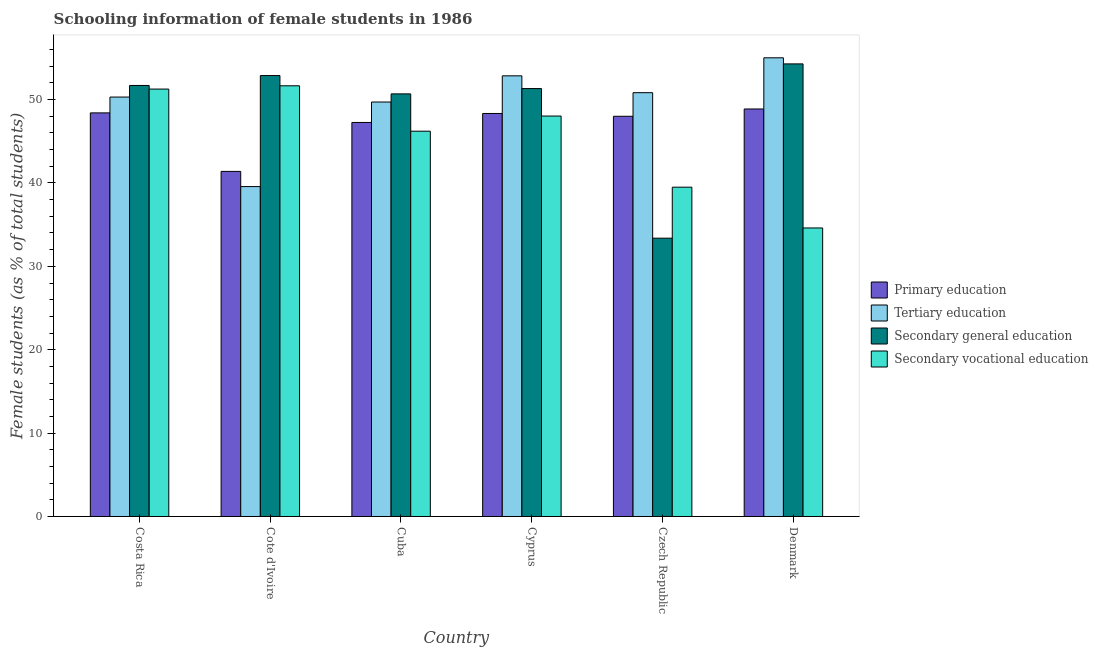How many different coloured bars are there?
Your answer should be very brief. 4. Are the number of bars on each tick of the X-axis equal?
Keep it short and to the point. Yes. How many bars are there on the 2nd tick from the left?
Keep it short and to the point. 4. How many bars are there on the 3rd tick from the right?
Your response must be concise. 4. What is the label of the 1st group of bars from the left?
Offer a very short reply. Costa Rica. What is the percentage of female students in secondary vocational education in Costa Rica?
Offer a very short reply. 51.26. Across all countries, what is the maximum percentage of female students in secondary vocational education?
Your answer should be very brief. 51.65. Across all countries, what is the minimum percentage of female students in secondary vocational education?
Keep it short and to the point. 34.6. In which country was the percentage of female students in secondary education minimum?
Make the answer very short. Czech Republic. What is the total percentage of female students in tertiary education in the graph?
Your answer should be compact. 298.27. What is the difference between the percentage of female students in tertiary education in Cote d'Ivoire and that in Cyprus?
Ensure brevity in your answer.  -13.28. What is the difference between the percentage of female students in secondary education in Cyprus and the percentage of female students in secondary vocational education in Cote d'Ivoire?
Provide a succinct answer. -0.33. What is the average percentage of female students in secondary vocational education per country?
Provide a short and direct response. 45.21. What is the difference between the percentage of female students in secondary vocational education and percentage of female students in primary education in Denmark?
Keep it short and to the point. -14.27. In how many countries, is the percentage of female students in secondary vocational education greater than 44 %?
Your answer should be very brief. 4. What is the ratio of the percentage of female students in tertiary education in Cote d'Ivoire to that in Czech Republic?
Offer a very short reply. 0.78. Is the percentage of female students in secondary education in Cote d'Ivoire less than that in Czech Republic?
Offer a terse response. No. Is the difference between the percentage of female students in tertiary education in Cote d'Ivoire and Cyprus greater than the difference between the percentage of female students in secondary education in Cote d'Ivoire and Cyprus?
Give a very brief answer. No. What is the difference between the highest and the second highest percentage of female students in tertiary education?
Make the answer very short. 2.16. What is the difference between the highest and the lowest percentage of female students in secondary education?
Keep it short and to the point. 20.9. In how many countries, is the percentage of female students in secondary vocational education greater than the average percentage of female students in secondary vocational education taken over all countries?
Offer a terse response. 4. What does the 4th bar from the left in Cyprus represents?
Ensure brevity in your answer.  Secondary vocational education. What does the 2nd bar from the right in Denmark represents?
Ensure brevity in your answer.  Secondary general education. Are all the bars in the graph horizontal?
Give a very brief answer. No. How many countries are there in the graph?
Offer a very short reply. 6. What is the difference between two consecutive major ticks on the Y-axis?
Provide a succinct answer. 10. Are the values on the major ticks of Y-axis written in scientific E-notation?
Your response must be concise. No. Where does the legend appear in the graph?
Offer a terse response. Center right. How many legend labels are there?
Your response must be concise. 4. What is the title of the graph?
Provide a succinct answer. Schooling information of female students in 1986. Does "Mammal species" appear as one of the legend labels in the graph?
Provide a succinct answer. No. What is the label or title of the X-axis?
Your answer should be compact. Country. What is the label or title of the Y-axis?
Provide a short and direct response. Female students (as % of total students). What is the Female students (as % of total students) in Primary education in Costa Rica?
Provide a succinct answer. 48.41. What is the Female students (as % of total students) of Tertiary education in Costa Rica?
Provide a succinct answer. 50.31. What is the Female students (as % of total students) in Secondary general education in Costa Rica?
Offer a very short reply. 51.7. What is the Female students (as % of total students) of Secondary vocational education in Costa Rica?
Ensure brevity in your answer.  51.26. What is the Female students (as % of total students) of Primary education in Cote d'Ivoire?
Provide a succinct answer. 41.39. What is the Female students (as % of total students) in Tertiary education in Cote d'Ivoire?
Keep it short and to the point. 39.57. What is the Female students (as % of total students) of Secondary general education in Cote d'Ivoire?
Offer a terse response. 52.88. What is the Female students (as % of total students) in Secondary vocational education in Cote d'Ivoire?
Make the answer very short. 51.65. What is the Female students (as % of total students) of Primary education in Cuba?
Provide a succinct answer. 47.26. What is the Female students (as % of total students) of Tertiary education in Cuba?
Your answer should be compact. 49.71. What is the Female students (as % of total students) of Secondary general education in Cuba?
Provide a short and direct response. 50.69. What is the Female students (as % of total students) in Secondary vocational education in Cuba?
Your response must be concise. 46.21. What is the Female students (as % of total students) in Primary education in Cyprus?
Your answer should be very brief. 48.33. What is the Female students (as % of total students) of Tertiary education in Cyprus?
Make the answer very short. 52.85. What is the Female students (as % of total students) of Secondary general education in Cyprus?
Offer a terse response. 51.32. What is the Female students (as % of total students) of Secondary vocational education in Cyprus?
Provide a short and direct response. 48.03. What is the Female students (as % of total students) in Primary education in Czech Republic?
Provide a succinct answer. 48. What is the Female students (as % of total students) of Tertiary education in Czech Republic?
Provide a succinct answer. 50.83. What is the Female students (as % of total students) of Secondary general education in Czech Republic?
Your answer should be very brief. 33.38. What is the Female students (as % of total students) in Secondary vocational education in Czech Republic?
Provide a succinct answer. 39.5. What is the Female students (as % of total students) of Primary education in Denmark?
Offer a very short reply. 48.88. What is the Female students (as % of total students) of Tertiary education in Denmark?
Make the answer very short. 55.01. What is the Female students (as % of total students) of Secondary general education in Denmark?
Your response must be concise. 54.28. What is the Female students (as % of total students) in Secondary vocational education in Denmark?
Provide a short and direct response. 34.6. Across all countries, what is the maximum Female students (as % of total students) of Primary education?
Keep it short and to the point. 48.88. Across all countries, what is the maximum Female students (as % of total students) in Tertiary education?
Ensure brevity in your answer.  55.01. Across all countries, what is the maximum Female students (as % of total students) in Secondary general education?
Keep it short and to the point. 54.28. Across all countries, what is the maximum Female students (as % of total students) in Secondary vocational education?
Keep it short and to the point. 51.65. Across all countries, what is the minimum Female students (as % of total students) of Primary education?
Your answer should be compact. 41.39. Across all countries, what is the minimum Female students (as % of total students) in Tertiary education?
Give a very brief answer. 39.57. Across all countries, what is the minimum Female students (as % of total students) in Secondary general education?
Ensure brevity in your answer.  33.38. Across all countries, what is the minimum Female students (as % of total students) of Secondary vocational education?
Give a very brief answer. 34.6. What is the total Female students (as % of total students) of Primary education in the graph?
Ensure brevity in your answer.  282.26. What is the total Female students (as % of total students) of Tertiary education in the graph?
Keep it short and to the point. 298.27. What is the total Female students (as % of total students) of Secondary general education in the graph?
Provide a succinct answer. 294.25. What is the total Female students (as % of total students) of Secondary vocational education in the graph?
Your answer should be very brief. 271.26. What is the difference between the Female students (as % of total students) in Primary education in Costa Rica and that in Cote d'Ivoire?
Offer a very short reply. 7.02. What is the difference between the Female students (as % of total students) in Tertiary education in Costa Rica and that in Cote d'Ivoire?
Give a very brief answer. 10.74. What is the difference between the Female students (as % of total students) of Secondary general education in Costa Rica and that in Cote d'Ivoire?
Provide a succinct answer. -1.19. What is the difference between the Female students (as % of total students) of Secondary vocational education in Costa Rica and that in Cote d'Ivoire?
Provide a short and direct response. -0.39. What is the difference between the Female students (as % of total students) of Primary education in Costa Rica and that in Cuba?
Your answer should be compact. 1.15. What is the difference between the Female students (as % of total students) in Tertiary education in Costa Rica and that in Cuba?
Give a very brief answer. 0.6. What is the difference between the Female students (as % of total students) in Secondary general education in Costa Rica and that in Cuba?
Provide a short and direct response. 1.01. What is the difference between the Female students (as % of total students) in Secondary vocational education in Costa Rica and that in Cuba?
Ensure brevity in your answer.  5.05. What is the difference between the Female students (as % of total students) of Primary education in Costa Rica and that in Cyprus?
Your answer should be compact. 0.07. What is the difference between the Female students (as % of total students) in Tertiary education in Costa Rica and that in Cyprus?
Ensure brevity in your answer.  -2.54. What is the difference between the Female students (as % of total students) of Secondary general education in Costa Rica and that in Cyprus?
Your response must be concise. 0.37. What is the difference between the Female students (as % of total students) in Secondary vocational education in Costa Rica and that in Cyprus?
Provide a short and direct response. 3.23. What is the difference between the Female students (as % of total students) of Primary education in Costa Rica and that in Czech Republic?
Give a very brief answer. 0.41. What is the difference between the Female students (as % of total students) in Tertiary education in Costa Rica and that in Czech Republic?
Offer a terse response. -0.53. What is the difference between the Female students (as % of total students) of Secondary general education in Costa Rica and that in Czech Republic?
Provide a succinct answer. 18.32. What is the difference between the Female students (as % of total students) in Secondary vocational education in Costa Rica and that in Czech Republic?
Your answer should be very brief. 11.77. What is the difference between the Female students (as % of total students) of Primary education in Costa Rica and that in Denmark?
Provide a short and direct response. -0.47. What is the difference between the Female students (as % of total students) of Tertiary education in Costa Rica and that in Denmark?
Give a very brief answer. -4.71. What is the difference between the Female students (as % of total students) of Secondary general education in Costa Rica and that in Denmark?
Give a very brief answer. -2.59. What is the difference between the Female students (as % of total students) of Secondary vocational education in Costa Rica and that in Denmark?
Offer a very short reply. 16.66. What is the difference between the Female students (as % of total students) of Primary education in Cote d'Ivoire and that in Cuba?
Give a very brief answer. -5.87. What is the difference between the Female students (as % of total students) of Tertiary education in Cote d'Ivoire and that in Cuba?
Provide a succinct answer. -10.14. What is the difference between the Female students (as % of total students) of Secondary general education in Cote d'Ivoire and that in Cuba?
Offer a terse response. 2.2. What is the difference between the Female students (as % of total students) of Secondary vocational education in Cote d'Ivoire and that in Cuba?
Provide a succinct answer. 5.44. What is the difference between the Female students (as % of total students) in Primary education in Cote d'Ivoire and that in Cyprus?
Offer a terse response. -6.95. What is the difference between the Female students (as % of total students) of Tertiary education in Cote d'Ivoire and that in Cyprus?
Provide a succinct answer. -13.28. What is the difference between the Female students (as % of total students) in Secondary general education in Cote d'Ivoire and that in Cyprus?
Give a very brief answer. 1.56. What is the difference between the Female students (as % of total students) in Secondary vocational education in Cote d'Ivoire and that in Cyprus?
Your answer should be compact. 3.63. What is the difference between the Female students (as % of total students) in Primary education in Cote d'Ivoire and that in Czech Republic?
Your answer should be very brief. -6.61. What is the difference between the Female students (as % of total students) of Tertiary education in Cote d'Ivoire and that in Czech Republic?
Your answer should be very brief. -11.26. What is the difference between the Female students (as % of total students) in Secondary general education in Cote d'Ivoire and that in Czech Republic?
Ensure brevity in your answer.  19.5. What is the difference between the Female students (as % of total students) in Secondary vocational education in Cote d'Ivoire and that in Czech Republic?
Offer a very short reply. 12.16. What is the difference between the Female students (as % of total students) in Primary education in Cote d'Ivoire and that in Denmark?
Offer a terse response. -7.49. What is the difference between the Female students (as % of total students) of Tertiary education in Cote d'Ivoire and that in Denmark?
Make the answer very short. -15.45. What is the difference between the Female students (as % of total students) in Secondary general education in Cote d'Ivoire and that in Denmark?
Your answer should be compact. -1.4. What is the difference between the Female students (as % of total students) of Secondary vocational education in Cote d'Ivoire and that in Denmark?
Offer a very short reply. 17.05. What is the difference between the Female students (as % of total students) of Primary education in Cuba and that in Cyprus?
Give a very brief answer. -1.08. What is the difference between the Female students (as % of total students) of Tertiary education in Cuba and that in Cyprus?
Keep it short and to the point. -3.14. What is the difference between the Female students (as % of total students) of Secondary general education in Cuba and that in Cyprus?
Ensure brevity in your answer.  -0.64. What is the difference between the Female students (as % of total students) of Secondary vocational education in Cuba and that in Cyprus?
Offer a very short reply. -1.82. What is the difference between the Female students (as % of total students) of Primary education in Cuba and that in Czech Republic?
Provide a short and direct response. -0.74. What is the difference between the Female students (as % of total students) of Tertiary education in Cuba and that in Czech Republic?
Your answer should be compact. -1.12. What is the difference between the Female students (as % of total students) of Secondary general education in Cuba and that in Czech Republic?
Your answer should be compact. 17.31. What is the difference between the Female students (as % of total students) in Secondary vocational education in Cuba and that in Czech Republic?
Provide a succinct answer. 6.71. What is the difference between the Female students (as % of total students) in Primary education in Cuba and that in Denmark?
Offer a terse response. -1.62. What is the difference between the Female students (as % of total students) of Tertiary education in Cuba and that in Denmark?
Keep it short and to the point. -5.3. What is the difference between the Female students (as % of total students) in Secondary general education in Cuba and that in Denmark?
Give a very brief answer. -3.6. What is the difference between the Female students (as % of total students) in Secondary vocational education in Cuba and that in Denmark?
Offer a terse response. 11.61. What is the difference between the Female students (as % of total students) in Primary education in Cyprus and that in Czech Republic?
Keep it short and to the point. 0.34. What is the difference between the Female students (as % of total students) of Tertiary education in Cyprus and that in Czech Republic?
Your answer should be very brief. 2.02. What is the difference between the Female students (as % of total students) of Secondary general education in Cyprus and that in Czech Republic?
Give a very brief answer. 17.94. What is the difference between the Female students (as % of total students) in Secondary vocational education in Cyprus and that in Czech Republic?
Your answer should be compact. 8.53. What is the difference between the Female students (as % of total students) in Primary education in Cyprus and that in Denmark?
Your response must be concise. -0.54. What is the difference between the Female students (as % of total students) of Tertiary education in Cyprus and that in Denmark?
Make the answer very short. -2.16. What is the difference between the Female students (as % of total students) of Secondary general education in Cyprus and that in Denmark?
Keep it short and to the point. -2.96. What is the difference between the Female students (as % of total students) in Secondary vocational education in Cyprus and that in Denmark?
Your response must be concise. 13.42. What is the difference between the Female students (as % of total students) in Primary education in Czech Republic and that in Denmark?
Ensure brevity in your answer.  -0.88. What is the difference between the Female students (as % of total students) of Tertiary education in Czech Republic and that in Denmark?
Ensure brevity in your answer.  -4.18. What is the difference between the Female students (as % of total students) in Secondary general education in Czech Republic and that in Denmark?
Give a very brief answer. -20.9. What is the difference between the Female students (as % of total students) of Secondary vocational education in Czech Republic and that in Denmark?
Ensure brevity in your answer.  4.89. What is the difference between the Female students (as % of total students) in Primary education in Costa Rica and the Female students (as % of total students) in Tertiary education in Cote d'Ivoire?
Make the answer very short. 8.84. What is the difference between the Female students (as % of total students) in Primary education in Costa Rica and the Female students (as % of total students) in Secondary general education in Cote d'Ivoire?
Your answer should be very brief. -4.48. What is the difference between the Female students (as % of total students) of Primary education in Costa Rica and the Female students (as % of total students) of Secondary vocational education in Cote d'Ivoire?
Give a very brief answer. -3.25. What is the difference between the Female students (as % of total students) of Tertiary education in Costa Rica and the Female students (as % of total students) of Secondary general education in Cote d'Ivoire?
Your response must be concise. -2.58. What is the difference between the Female students (as % of total students) in Tertiary education in Costa Rica and the Female students (as % of total students) in Secondary vocational education in Cote d'Ivoire?
Offer a very short reply. -1.35. What is the difference between the Female students (as % of total students) of Secondary general education in Costa Rica and the Female students (as % of total students) of Secondary vocational education in Cote d'Ivoire?
Your answer should be compact. 0.04. What is the difference between the Female students (as % of total students) in Primary education in Costa Rica and the Female students (as % of total students) in Tertiary education in Cuba?
Your answer should be compact. -1.3. What is the difference between the Female students (as % of total students) in Primary education in Costa Rica and the Female students (as % of total students) in Secondary general education in Cuba?
Your answer should be compact. -2.28. What is the difference between the Female students (as % of total students) in Primary education in Costa Rica and the Female students (as % of total students) in Secondary vocational education in Cuba?
Your answer should be very brief. 2.2. What is the difference between the Female students (as % of total students) in Tertiary education in Costa Rica and the Female students (as % of total students) in Secondary general education in Cuba?
Your answer should be very brief. -0.38. What is the difference between the Female students (as % of total students) of Tertiary education in Costa Rica and the Female students (as % of total students) of Secondary vocational education in Cuba?
Make the answer very short. 4.09. What is the difference between the Female students (as % of total students) of Secondary general education in Costa Rica and the Female students (as % of total students) of Secondary vocational education in Cuba?
Keep it short and to the point. 5.48. What is the difference between the Female students (as % of total students) of Primary education in Costa Rica and the Female students (as % of total students) of Tertiary education in Cyprus?
Offer a terse response. -4.44. What is the difference between the Female students (as % of total students) of Primary education in Costa Rica and the Female students (as % of total students) of Secondary general education in Cyprus?
Provide a short and direct response. -2.92. What is the difference between the Female students (as % of total students) in Primary education in Costa Rica and the Female students (as % of total students) in Secondary vocational education in Cyprus?
Provide a short and direct response. 0.38. What is the difference between the Female students (as % of total students) of Tertiary education in Costa Rica and the Female students (as % of total students) of Secondary general education in Cyprus?
Offer a terse response. -1.02. What is the difference between the Female students (as % of total students) of Tertiary education in Costa Rica and the Female students (as % of total students) of Secondary vocational education in Cyprus?
Give a very brief answer. 2.28. What is the difference between the Female students (as % of total students) of Secondary general education in Costa Rica and the Female students (as % of total students) of Secondary vocational education in Cyprus?
Your answer should be compact. 3.67. What is the difference between the Female students (as % of total students) in Primary education in Costa Rica and the Female students (as % of total students) in Tertiary education in Czech Republic?
Keep it short and to the point. -2.42. What is the difference between the Female students (as % of total students) in Primary education in Costa Rica and the Female students (as % of total students) in Secondary general education in Czech Republic?
Provide a short and direct response. 15.03. What is the difference between the Female students (as % of total students) in Primary education in Costa Rica and the Female students (as % of total students) in Secondary vocational education in Czech Republic?
Give a very brief answer. 8.91. What is the difference between the Female students (as % of total students) of Tertiary education in Costa Rica and the Female students (as % of total students) of Secondary general education in Czech Republic?
Offer a very short reply. 16.93. What is the difference between the Female students (as % of total students) of Tertiary education in Costa Rica and the Female students (as % of total students) of Secondary vocational education in Czech Republic?
Your answer should be very brief. 10.81. What is the difference between the Female students (as % of total students) in Secondary general education in Costa Rica and the Female students (as % of total students) in Secondary vocational education in Czech Republic?
Keep it short and to the point. 12.2. What is the difference between the Female students (as % of total students) of Primary education in Costa Rica and the Female students (as % of total students) of Tertiary education in Denmark?
Ensure brevity in your answer.  -6.61. What is the difference between the Female students (as % of total students) in Primary education in Costa Rica and the Female students (as % of total students) in Secondary general education in Denmark?
Provide a succinct answer. -5.88. What is the difference between the Female students (as % of total students) in Primary education in Costa Rica and the Female students (as % of total students) in Secondary vocational education in Denmark?
Make the answer very short. 13.8. What is the difference between the Female students (as % of total students) of Tertiary education in Costa Rica and the Female students (as % of total students) of Secondary general education in Denmark?
Make the answer very short. -3.98. What is the difference between the Female students (as % of total students) in Tertiary education in Costa Rica and the Female students (as % of total students) in Secondary vocational education in Denmark?
Keep it short and to the point. 15.7. What is the difference between the Female students (as % of total students) of Secondary general education in Costa Rica and the Female students (as % of total students) of Secondary vocational education in Denmark?
Ensure brevity in your answer.  17.09. What is the difference between the Female students (as % of total students) in Primary education in Cote d'Ivoire and the Female students (as % of total students) in Tertiary education in Cuba?
Ensure brevity in your answer.  -8.32. What is the difference between the Female students (as % of total students) in Primary education in Cote d'Ivoire and the Female students (as % of total students) in Secondary general education in Cuba?
Make the answer very short. -9.3. What is the difference between the Female students (as % of total students) in Primary education in Cote d'Ivoire and the Female students (as % of total students) in Secondary vocational education in Cuba?
Your answer should be compact. -4.82. What is the difference between the Female students (as % of total students) in Tertiary education in Cote d'Ivoire and the Female students (as % of total students) in Secondary general education in Cuba?
Your response must be concise. -11.12. What is the difference between the Female students (as % of total students) in Tertiary education in Cote d'Ivoire and the Female students (as % of total students) in Secondary vocational education in Cuba?
Your response must be concise. -6.64. What is the difference between the Female students (as % of total students) of Secondary general education in Cote d'Ivoire and the Female students (as % of total students) of Secondary vocational education in Cuba?
Give a very brief answer. 6.67. What is the difference between the Female students (as % of total students) of Primary education in Cote d'Ivoire and the Female students (as % of total students) of Tertiary education in Cyprus?
Your answer should be very brief. -11.46. What is the difference between the Female students (as % of total students) in Primary education in Cote d'Ivoire and the Female students (as % of total students) in Secondary general education in Cyprus?
Make the answer very short. -9.93. What is the difference between the Female students (as % of total students) of Primary education in Cote d'Ivoire and the Female students (as % of total students) of Secondary vocational education in Cyprus?
Provide a succinct answer. -6.64. What is the difference between the Female students (as % of total students) in Tertiary education in Cote d'Ivoire and the Female students (as % of total students) in Secondary general education in Cyprus?
Offer a very short reply. -11.76. What is the difference between the Female students (as % of total students) of Tertiary education in Cote d'Ivoire and the Female students (as % of total students) of Secondary vocational education in Cyprus?
Offer a terse response. -8.46. What is the difference between the Female students (as % of total students) of Secondary general education in Cote d'Ivoire and the Female students (as % of total students) of Secondary vocational education in Cyprus?
Make the answer very short. 4.86. What is the difference between the Female students (as % of total students) in Primary education in Cote d'Ivoire and the Female students (as % of total students) in Tertiary education in Czech Republic?
Your response must be concise. -9.44. What is the difference between the Female students (as % of total students) of Primary education in Cote d'Ivoire and the Female students (as % of total students) of Secondary general education in Czech Republic?
Provide a succinct answer. 8.01. What is the difference between the Female students (as % of total students) of Primary education in Cote d'Ivoire and the Female students (as % of total students) of Secondary vocational education in Czech Republic?
Keep it short and to the point. 1.89. What is the difference between the Female students (as % of total students) of Tertiary education in Cote d'Ivoire and the Female students (as % of total students) of Secondary general education in Czech Republic?
Give a very brief answer. 6.19. What is the difference between the Female students (as % of total students) in Tertiary education in Cote d'Ivoire and the Female students (as % of total students) in Secondary vocational education in Czech Republic?
Your answer should be very brief. 0.07. What is the difference between the Female students (as % of total students) of Secondary general education in Cote d'Ivoire and the Female students (as % of total students) of Secondary vocational education in Czech Republic?
Provide a short and direct response. 13.39. What is the difference between the Female students (as % of total students) of Primary education in Cote d'Ivoire and the Female students (as % of total students) of Tertiary education in Denmark?
Offer a terse response. -13.62. What is the difference between the Female students (as % of total students) in Primary education in Cote d'Ivoire and the Female students (as % of total students) in Secondary general education in Denmark?
Provide a succinct answer. -12.89. What is the difference between the Female students (as % of total students) of Primary education in Cote d'Ivoire and the Female students (as % of total students) of Secondary vocational education in Denmark?
Make the answer very short. 6.78. What is the difference between the Female students (as % of total students) in Tertiary education in Cote d'Ivoire and the Female students (as % of total students) in Secondary general education in Denmark?
Offer a terse response. -14.72. What is the difference between the Female students (as % of total students) of Tertiary education in Cote d'Ivoire and the Female students (as % of total students) of Secondary vocational education in Denmark?
Ensure brevity in your answer.  4.96. What is the difference between the Female students (as % of total students) of Secondary general education in Cote d'Ivoire and the Female students (as % of total students) of Secondary vocational education in Denmark?
Make the answer very short. 18.28. What is the difference between the Female students (as % of total students) of Primary education in Cuba and the Female students (as % of total students) of Tertiary education in Cyprus?
Keep it short and to the point. -5.59. What is the difference between the Female students (as % of total students) of Primary education in Cuba and the Female students (as % of total students) of Secondary general education in Cyprus?
Ensure brevity in your answer.  -4.07. What is the difference between the Female students (as % of total students) of Primary education in Cuba and the Female students (as % of total students) of Secondary vocational education in Cyprus?
Offer a terse response. -0.77. What is the difference between the Female students (as % of total students) of Tertiary education in Cuba and the Female students (as % of total students) of Secondary general education in Cyprus?
Make the answer very short. -1.61. What is the difference between the Female students (as % of total students) of Tertiary education in Cuba and the Female students (as % of total students) of Secondary vocational education in Cyprus?
Make the answer very short. 1.68. What is the difference between the Female students (as % of total students) in Secondary general education in Cuba and the Female students (as % of total students) in Secondary vocational education in Cyprus?
Make the answer very short. 2.66. What is the difference between the Female students (as % of total students) of Primary education in Cuba and the Female students (as % of total students) of Tertiary education in Czech Republic?
Make the answer very short. -3.57. What is the difference between the Female students (as % of total students) in Primary education in Cuba and the Female students (as % of total students) in Secondary general education in Czech Republic?
Your answer should be very brief. 13.88. What is the difference between the Female students (as % of total students) of Primary education in Cuba and the Female students (as % of total students) of Secondary vocational education in Czech Republic?
Your answer should be very brief. 7.76. What is the difference between the Female students (as % of total students) in Tertiary education in Cuba and the Female students (as % of total students) in Secondary general education in Czech Republic?
Your answer should be compact. 16.33. What is the difference between the Female students (as % of total students) of Tertiary education in Cuba and the Female students (as % of total students) of Secondary vocational education in Czech Republic?
Provide a succinct answer. 10.21. What is the difference between the Female students (as % of total students) of Secondary general education in Cuba and the Female students (as % of total students) of Secondary vocational education in Czech Republic?
Give a very brief answer. 11.19. What is the difference between the Female students (as % of total students) of Primary education in Cuba and the Female students (as % of total students) of Tertiary education in Denmark?
Offer a terse response. -7.75. What is the difference between the Female students (as % of total students) in Primary education in Cuba and the Female students (as % of total students) in Secondary general education in Denmark?
Offer a terse response. -7.03. What is the difference between the Female students (as % of total students) of Primary education in Cuba and the Female students (as % of total students) of Secondary vocational education in Denmark?
Provide a succinct answer. 12.65. What is the difference between the Female students (as % of total students) in Tertiary education in Cuba and the Female students (as % of total students) in Secondary general education in Denmark?
Give a very brief answer. -4.57. What is the difference between the Female students (as % of total students) in Tertiary education in Cuba and the Female students (as % of total students) in Secondary vocational education in Denmark?
Offer a terse response. 15.1. What is the difference between the Female students (as % of total students) in Secondary general education in Cuba and the Female students (as % of total students) in Secondary vocational education in Denmark?
Ensure brevity in your answer.  16.08. What is the difference between the Female students (as % of total students) of Primary education in Cyprus and the Female students (as % of total students) of Tertiary education in Czech Republic?
Ensure brevity in your answer.  -2.5. What is the difference between the Female students (as % of total students) in Primary education in Cyprus and the Female students (as % of total students) in Secondary general education in Czech Republic?
Ensure brevity in your answer.  14.96. What is the difference between the Female students (as % of total students) in Primary education in Cyprus and the Female students (as % of total students) in Secondary vocational education in Czech Republic?
Your response must be concise. 8.84. What is the difference between the Female students (as % of total students) of Tertiary education in Cyprus and the Female students (as % of total students) of Secondary general education in Czech Republic?
Make the answer very short. 19.47. What is the difference between the Female students (as % of total students) in Tertiary education in Cyprus and the Female students (as % of total students) in Secondary vocational education in Czech Republic?
Ensure brevity in your answer.  13.35. What is the difference between the Female students (as % of total students) in Secondary general education in Cyprus and the Female students (as % of total students) in Secondary vocational education in Czech Republic?
Give a very brief answer. 11.83. What is the difference between the Female students (as % of total students) in Primary education in Cyprus and the Female students (as % of total students) in Tertiary education in Denmark?
Provide a succinct answer. -6.68. What is the difference between the Female students (as % of total students) in Primary education in Cyprus and the Female students (as % of total students) in Secondary general education in Denmark?
Provide a short and direct response. -5.95. What is the difference between the Female students (as % of total students) in Primary education in Cyprus and the Female students (as % of total students) in Secondary vocational education in Denmark?
Provide a short and direct response. 13.73. What is the difference between the Female students (as % of total students) of Tertiary education in Cyprus and the Female students (as % of total students) of Secondary general education in Denmark?
Your answer should be very brief. -1.43. What is the difference between the Female students (as % of total students) in Tertiary education in Cyprus and the Female students (as % of total students) in Secondary vocational education in Denmark?
Provide a short and direct response. 18.25. What is the difference between the Female students (as % of total students) in Secondary general education in Cyprus and the Female students (as % of total students) in Secondary vocational education in Denmark?
Offer a terse response. 16.72. What is the difference between the Female students (as % of total students) of Primary education in Czech Republic and the Female students (as % of total students) of Tertiary education in Denmark?
Your answer should be compact. -7.01. What is the difference between the Female students (as % of total students) in Primary education in Czech Republic and the Female students (as % of total students) in Secondary general education in Denmark?
Provide a succinct answer. -6.28. What is the difference between the Female students (as % of total students) in Primary education in Czech Republic and the Female students (as % of total students) in Secondary vocational education in Denmark?
Make the answer very short. 13.39. What is the difference between the Female students (as % of total students) of Tertiary education in Czech Republic and the Female students (as % of total students) of Secondary general education in Denmark?
Give a very brief answer. -3.45. What is the difference between the Female students (as % of total students) in Tertiary education in Czech Republic and the Female students (as % of total students) in Secondary vocational education in Denmark?
Offer a very short reply. 16.23. What is the difference between the Female students (as % of total students) in Secondary general education in Czech Republic and the Female students (as % of total students) in Secondary vocational education in Denmark?
Your answer should be compact. -1.23. What is the average Female students (as % of total students) in Primary education per country?
Your response must be concise. 47.04. What is the average Female students (as % of total students) in Tertiary education per country?
Your answer should be very brief. 49.71. What is the average Female students (as % of total students) of Secondary general education per country?
Offer a terse response. 49.04. What is the average Female students (as % of total students) of Secondary vocational education per country?
Make the answer very short. 45.21. What is the difference between the Female students (as % of total students) in Primary education and Female students (as % of total students) in Tertiary education in Costa Rica?
Ensure brevity in your answer.  -1.9. What is the difference between the Female students (as % of total students) in Primary education and Female students (as % of total students) in Secondary general education in Costa Rica?
Offer a terse response. -3.29. What is the difference between the Female students (as % of total students) of Primary education and Female students (as % of total students) of Secondary vocational education in Costa Rica?
Ensure brevity in your answer.  -2.86. What is the difference between the Female students (as % of total students) of Tertiary education and Female students (as % of total students) of Secondary general education in Costa Rica?
Your answer should be very brief. -1.39. What is the difference between the Female students (as % of total students) of Tertiary education and Female students (as % of total students) of Secondary vocational education in Costa Rica?
Your response must be concise. -0.96. What is the difference between the Female students (as % of total students) in Secondary general education and Female students (as % of total students) in Secondary vocational education in Costa Rica?
Provide a short and direct response. 0.43. What is the difference between the Female students (as % of total students) in Primary education and Female students (as % of total students) in Tertiary education in Cote d'Ivoire?
Your answer should be very brief. 1.82. What is the difference between the Female students (as % of total students) in Primary education and Female students (as % of total students) in Secondary general education in Cote d'Ivoire?
Provide a succinct answer. -11.5. What is the difference between the Female students (as % of total students) of Primary education and Female students (as % of total students) of Secondary vocational education in Cote d'Ivoire?
Your response must be concise. -10.27. What is the difference between the Female students (as % of total students) of Tertiary education and Female students (as % of total students) of Secondary general education in Cote d'Ivoire?
Offer a very short reply. -13.32. What is the difference between the Female students (as % of total students) of Tertiary education and Female students (as % of total students) of Secondary vocational education in Cote d'Ivoire?
Provide a short and direct response. -12.09. What is the difference between the Female students (as % of total students) of Secondary general education and Female students (as % of total students) of Secondary vocational education in Cote d'Ivoire?
Give a very brief answer. 1.23. What is the difference between the Female students (as % of total students) of Primary education and Female students (as % of total students) of Tertiary education in Cuba?
Your answer should be compact. -2.45. What is the difference between the Female students (as % of total students) of Primary education and Female students (as % of total students) of Secondary general education in Cuba?
Ensure brevity in your answer.  -3.43. What is the difference between the Female students (as % of total students) of Primary education and Female students (as % of total students) of Secondary vocational education in Cuba?
Your response must be concise. 1.05. What is the difference between the Female students (as % of total students) in Tertiary education and Female students (as % of total students) in Secondary general education in Cuba?
Provide a succinct answer. -0.98. What is the difference between the Female students (as % of total students) in Tertiary education and Female students (as % of total students) in Secondary vocational education in Cuba?
Your answer should be compact. 3.5. What is the difference between the Female students (as % of total students) in Secondary general education and Female students (as % of total students) in Secondary vocational education in Cuba?
Give a very brief answer. 4.47. What is the difference between the Female students (as % of total students) in Primary education and Female students (as % of total students) in Tertiary education in Cyprus?
Offer a very short reply. -4.52. What is the difference between the Female students (as % of total students) in Primary education and Female students (as % of total students) in Secondary general education in Cyprus?
Your answer should be compact. -2.99. What is the difference between the Female students (as % of total students) in Primary education and Female students (as % of total students) in Secondary vocational education in Cyprus?
Keep it short and to the point. 0.31. What is the difference between the Female students (as % of total students) of Tertiary education and Female students (as % of total students) of Secondary general education in Cyprus?
Your answer should be compact. 1.53. What is the difference between the Female students (as % of total students) of Tertiary education and Female students (as % of total students) of Secondary vocational education in Cyprus?
Offer a terse response. 4.82. What is the difference between the Female students (as % of total students) of Secondary general education and Female students (as % of total students) of Secondary vocational education in Cyprus?
Your response must be concise. 3.29. What is the difference between the Female students (as % of total students) in Primary education and Female students (as % of total students) in Tertiary education in Czech Republic?
Provide a succinct answer. -2.83. What is the difference between the Female students (as % of total students) in Primary education and Female students (as % of total students) in Secondary general education in Czech Republic?
Provide a short and direct response. 14.62. What is the difference between the Female students (as % of total students) of Primary education and Female students (as % of total students) of Secondary vocational education in Czech Republic?
Your response must be concise. 8.5. What is the difference between the Female students (as % of total students) of Tertiary education and Female students (as % of total students) of Secondary general education in Czech Republic?
Offer a terse response. 17.45. What is the difference between the Female students (as % of total students) of Tertiary education and Female students (as % of total students) of Secondary vocational education in Czech Republic?
Offer a very short reply. 11.33. What is the difference between the Female students (as % of total students) of Secondary general education and Female students (as % of total students) of Secondary vocational education in Czech Republic?
Make the answer very short. -6.12. What is the difference between the Female students (as % of total students) of Primary education and Female students (as % of total students) of Tertiary education in Denmark?
Keep it short and to the point. -6.14. What is the difference between the Female students (as % of total students) of Primary education and Female students (as % of total students) of Secondary general education in Denmark?
Ensure brevity in your answer.  -5.41. What is the difference between the Female students (as % of total students) in Primary education and Female students (as % of total students) in Secondary vocational education in Denmark?
Make the answer very short. 14.27. What is the difference between the Female students (as % of total students) of Tertiary education and Female students (as % of total students) of Secondary general education in Denmark?
Your response must be concise. 0.73. What is the difference between the Female students (as % of total students) in Tertiary education and Female students (as % of total students) in Secondary vocational education in Denmark?
Your answer should be very brief. 20.41. What is the difference between the Female students (as % of total students) of Secondary general education and Female students (as % of total students) of Secondary vocational education in Denmark?
Provide a succinct answer. 19.68. What is the ratio of the Female students (as % of total students) of Primary education in Costa Rica to that in Cote d'Ivoire?
Your answer should be compact. 1.17. What is the ratio of the Female students (as % of total students) in Tertiary education in Costa Rica to that in Cote d'Ivoire?
Provide a succinct answer. 1.27. What is the ratio of the Female students (as % of total students) in Secondary general education in Costa Rica to that in Cote d'Ivoire?
Provide a succinct answer. 0.98. What is the ratio of the Female students (as % of total students) of Secondary vocational education in Costa Rica to that in Cote d'Ivoire?
Make the answer very short. 0.99. What is the ratio of the Female students (as % of total students) in Primary education in Costa Rica to that in Cuba?
Offer a very short reply. 1.02. What is the ratio of the Female students (as % of total students) of Tertiary education in Costa Rica to that in Cuba?
Provide a succinct answer. 1.01. What is the ratio of the Female students (as % of total students) in Secondary general education in Costa Rica to that in Cuba?
Offer a very short reply. 1.02. What is the ratio of the Female students (as % of total students) of Secondary vocational education in Costa Rica to that in Cuba?
Offer a terse response. 1.11. What is the ratio of the Female students (as % of total students) in Primary education in Costa Rica to that in Cyprus?
Make the answer very short. 1. What is the ratio of the Female students (as % of total students) of Tertiary education in Costa Rica to that in Cyprus?
Your answer should be compact. 0.95. What is the ratio of the Female students (as % of total students) of Secondary general education in Costa Rica to that in Cyprus?
Your answer should be very brief. 1.01. What is the ratio of the Female students (as % of total students) of Secondary vocational education in Costa Rica to that in Cyprus?
Make the answer very short. 1.07. What is the ratio of the Female students (as % of total students) in Primary education in Costa Rica to that in Czech Republic?
Ensure brevity in your answer.  1.01. What is the ratio of the Female students (as % of total students) in Secondary general education in Costa Rica to that in Czech Republic?
Your response must be concise. 1.55. What is the ratio of the Female students (as % of total students) of Secondary vocational education in Costa Rica to that in Czech Republic?
Give a very brief answer. 1.3. What is the ratio of the Female students (as % of total students) in Tertiary education in Costa Rica to that in Denmark?
Ensure brevity in your answer.  0.91. What is the ratio of the Female students (as % of total students) of Secondary general education in Costa Rica to that in Denmark?
Your response must be concise. 0.95. What is the ratio of the Female students (as % of total students) in Secondary vocational education in Costa Rica to that in Denmark?
Your response must be concise. 1.48. What is the ratio of the Female students (as % of total students) of Primary education in Cote d'Ivoire to that in Cuba?
Your response must be concise. 0.88. What is the ratio of the Female students (as % of total students) of Tertiary education in Cote d'Ivoire to that in Cuba?
Your answer should be compact. 0.8. What is the ratio of the Female students (as % of total students) in Secondary general education in Cote d'Ivoire to that in Cuba?
Provide a succinct answer. 1.04. What is the ratio of the Female students (as % of total students) of Secondary vocational education in Cote d'Ivoire to that in Cuba?
Offer a very short reply. 1.12. What is the ratio of the Female students (as % of total students) of Primary education in Cote d'Ivoire to that in Cyprus?
Give a very brief answer. 0.86. What is the ratio of the Female students (as % of total students) in Tertiary education in Cote d'Ivoire to that in Cyprus?
Provide a succinct answer. 0.75. What is the ratio of the Female students (as % of total students) in Secondary general education in Cote d'Ivoire to that in Cyprus?
Provide a short and direct response. 1.03. What is the ratio of the Female students (as % of total students) of Secondary vocational education in Cote d'Ivoire to that in Cyprus?
Keep it short and to the point. 1.08. What is the ratio of the Female students (as % of total students) in Primary education in Cote d'Ivoire to that in Czech Republic?
Your answer should be very brief. 0.86. What is the ratio of the Female students (as % of total students) of Tertiary education in Cote d'Ivoire to that in Czech Republic?
Your response must be concise. 0.78. What is the ratio of the Female students (as % of total students) in Secondary general education in Cote d'Ivoire to that in Czech Republic?
Provide a succinct answer. 1.58. What is the ratio of the Female students (as % of total students) of Secondary vocational education in Cote d'Ivoire to that in Czech Republic?
Your answer should be very brief. 1.31. What is the ratio of the Female students (as % of total students) in Primary education in Cote d'Ivoire to that in Denmark?
Offer a very short reply. 0.85. What is the ratio of the Female students (as % of total students) in Tertiary education in Cote d'Ivoire to that in Denmark?
Your answer should be compact. 0.72. What is the ratio of the Female students (as % of total students) in Secondary general education in Cote d'Ivoire to that in Denmark?
Your answer should be compact. 0.97. What is the ratio of the Female students (as % of total students) of Secondary vocational education in Cote d'Ivoire to that in Denmark?
Your answer should be very brief. 1.49. What is the ratio of the Female students (as % of total students) of Primary education in Cuba to that in Cyprus?
Keep it short and to the point. 0.98. What is the ratio of the Female students (as % of total students) in Tertiary education in Cuba to that in Cyprus?
Provide a short and direct response. 0.94. What is the ratio of the Female students (as % of total students) in Secondary general education in Cuba to that in Cyprus?
Provide a short and direct response. 0.99. What is the ratio of the Female students (as % of total students) in Secondary vocational education in Cuba to that in Cyprus?
Offer a terse response. 0.96. What is the ratio of the Female students (as % of total students) in Primary education in Cuba to that in Czech Republic?
Offer a very short reply. 0.98. What is the ratio of the Female students (as % of total students) in Tertiary education in Cuba to that in Czech Republic?
Keep it short and to the point. 0.98. What is the ratio of the Female students (as % of total students) of Secondary general education in Cuba to that in Czech Republic?
Keep it short and to the point. 1.52. What is the ratio of the Female students (as % of total students) in Secondary vocational education in Cuba to that in Czech Republic?
Your answer should be compact. 1.17. What is the ratio of the Female students (as % of total students) of Primary education in Cuba to that in Denmark?
Provide a short and direct response. 0.97. What is the ratio of the Female students (as % of total students) in Tertiary education in Cuba to that in Denmark?
Make the answer very short. 0.9. What is the ratio of the Female students (as % of total students) in Secondary general education in Cuba to that in Denmark?
Your response must be concise. 0.93. What is the ratio of the Female students (as % of total students) in Secondary vocational education in Cuba to that in Denmark?
Give a very brief answer. 1.34. What is the ratio of the Female students (as % of total students) in Tertiary education in Cyprus to that in Czech Republic?
Offer a very short reply. 1.04. What is the ratio of the Female students (as % of total students) of Secondary general education in Cyprus to that in Czech Republic?
Ensure brevity in your answer.  1.54. What is the ratio of the Female students (as % of total students) in Secondary vocational education in Cyprus to that in Czech Republic?
Give a very brief answer. 1.22. What is the ratio of the Female students (as % of total students) of Primary education in Cyprus to that in Denmark?
Offer a terse response. 0.99. What is the ratio of the Female students (as % of total students) in Tertiary education in Cyprus to that in Denmark?
Make the answer very short. 0.96. What is the ratio of the Female students (as % of total students) of Secondary general education in Cyprus to that in Denmark?
Give a very brief answer. 0.95. What is the ratio of the Female students (as % of total students) of Secondary vocational education in Cyprus to that in Denmark?
Keep it short and to the point. 1.39. What is the ratio of the Female students (as % of total students) of Primary education in Czech Republic to that in Denmark?
Ensure brevity in your answer.  0.98. What is the ratio of the Female students (as % of total students) of Tertiary education in Czech Republic to that in Denmark?
Your response must be concise. 0.92. What is the ratio of the Female students (as % of total students) in Secondary general education in Czech Republic to that in Denmark?
Make the answer very short. 0.61. What is the ratio of the Female students (as % of total students) of Secondary vocational education in Czech Republic to that in Denmark?
Give a very brief answer. 1.14. What is the difference between the highest and the second highest Female students (as % of total students) in Primary education?
Provide a succinct answer. 0.47. What is the difference between the highest and the second highest Female students (as % of total students) of Tertiary education?
Your answer should be compact. 2.16. What is the difference between the highest and the second highest Female students (as % of total students) of Secondary general education?
Your answer should be compact. 1.4. What is the difference between the highest and the second highest Female students (as % of total students) of Secondary vocational education?
Offer a terse response. 0.39. What is the difference between the highest and the lowest Female students (as % of total students) in Primary education?
Ensure brevity in your answer.  7.49. What is the difference between the highest and the lowest Female students (as % of total students) in Tertiary education?
Offer a very short reply. 15.45. What is the difference between the highest and the lowest Female students (as % of total students) of Secondary general education?
Your answer should be compact. 20.9. What is the difference between the highest and the lowest Female students (as % of total students) in Secondary vocational education?
Ensure brevity in your answer.  17.05. 